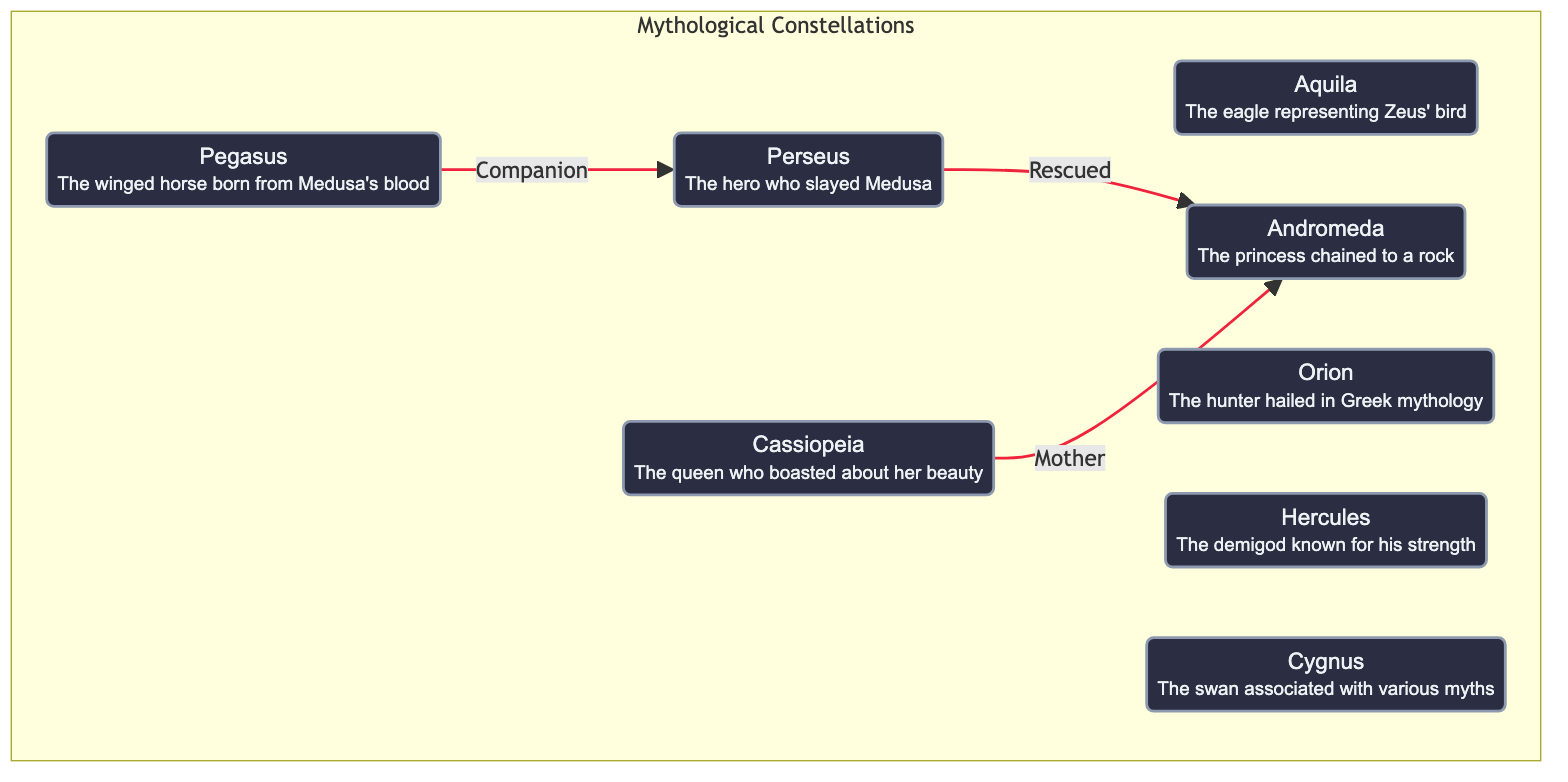What is the relationship between Perseus and Andromeda? The diagram indicates that Perseus is connected to Andromeda with the label "Rescued," indicating that Perseus rescued Andromeda from danger, reinforcing their mythological connection.
Answer: Rescued How many constellations are represented in the diagram? By counting the nodes in the "Mythological Constellations" subgraph, I find a total of eight constellations: Aquila, Orion, Perseus, Andromeda, Pegasus, Cassiopeia, Hercules, and Cygnus.
Answer: 8 Who is the mother of Andromeda according to the diagram? The diagram shows a link from Cassiopeia to Andromeda with the label "Mother," which directly indicates that Cassiopeia is the mother figure for Andromeda in the mythological context.
Answer: Cassiopeia What is the name of the constellation associated with Zeus' bird? The diagram identifies Aquila as the constellation that represents Zeus' bird, and this is noted in the small description under the Aquila node in the diagram.
Answer: Aquila Which constellation is noted for its association with a winged horse? The diagram specifically mentions Pegasus as the constellation that is the "winged horse born from Medusa's blood," as indicated in its descriptive text.
Answer: Pegasus How is Perseus related to Pegasus in the diagram? The diagram shows a direct connection between Perseus and Pegasus labeled "Companion," indicating that Pegasus serves as a companion to Perseus within the mythological narrative.
Answer: Companion What is the significance of Cygnus in this diagram? The diagram describes Cygnus as "The swan associated with various myths," noting its role but without a direct connection to any other constellations shown.
Answer: Associated with various myths Which constellation is identified as the hunter in Greek mythology? Orion is specifically labeled in the diagram with "The hunter hailed in Greek mythology," making it clear that this constellation is named after a mythological figure known for hunting.
Answer: Orion 